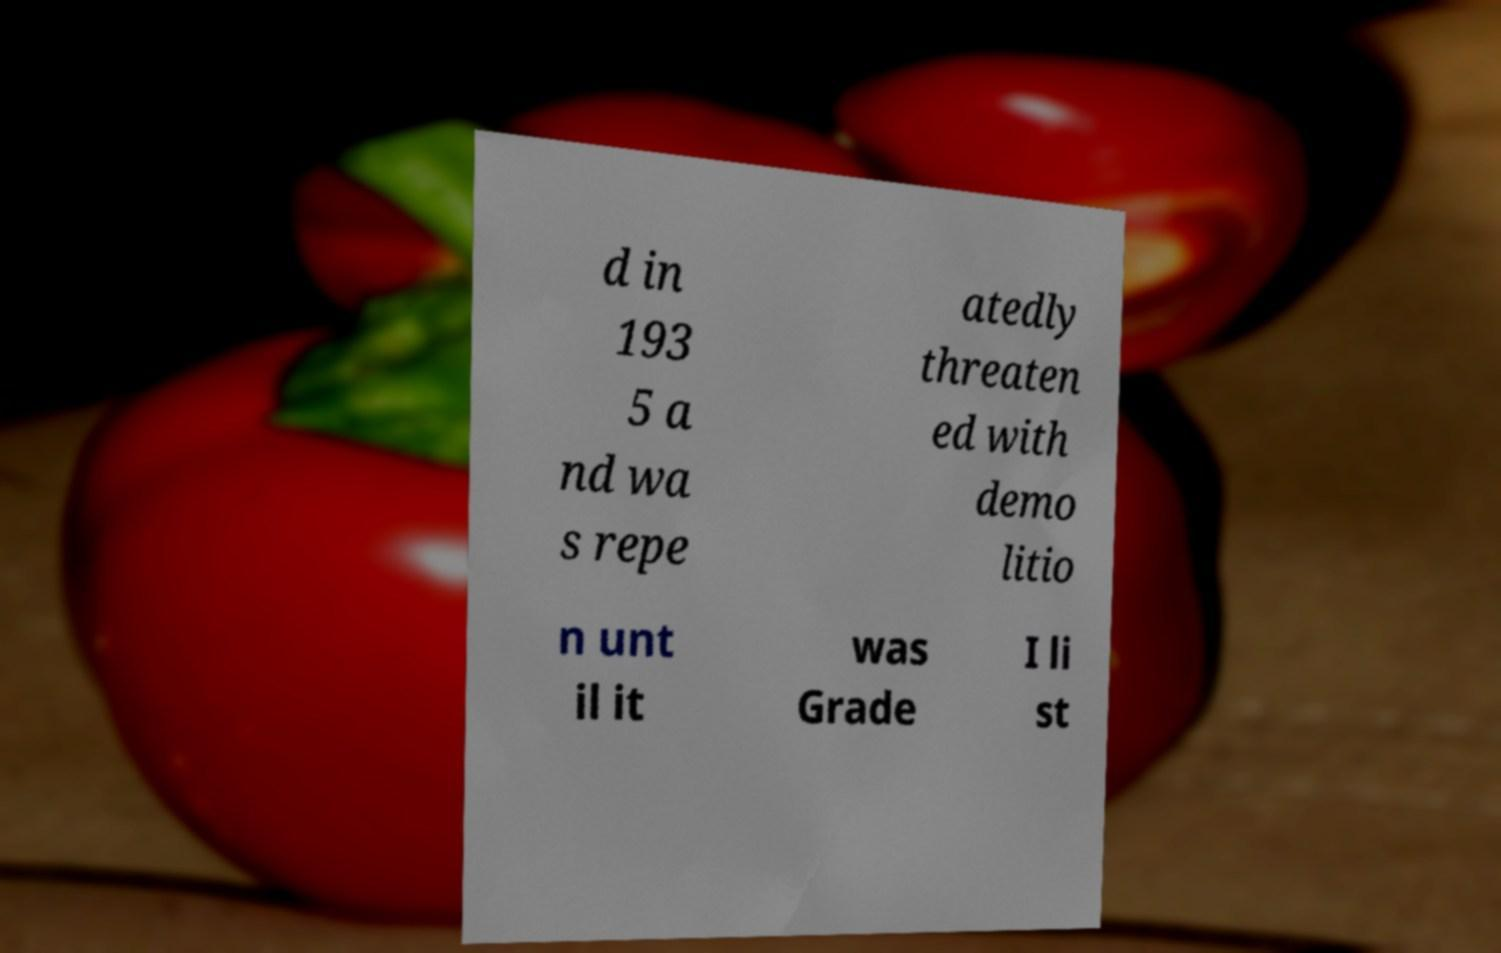I need the written content from this picture converted into text. Can you do that? d in 193 5 a nd wa s repe atedly threaten ed with demo litio n unt il it was Grade I li st 